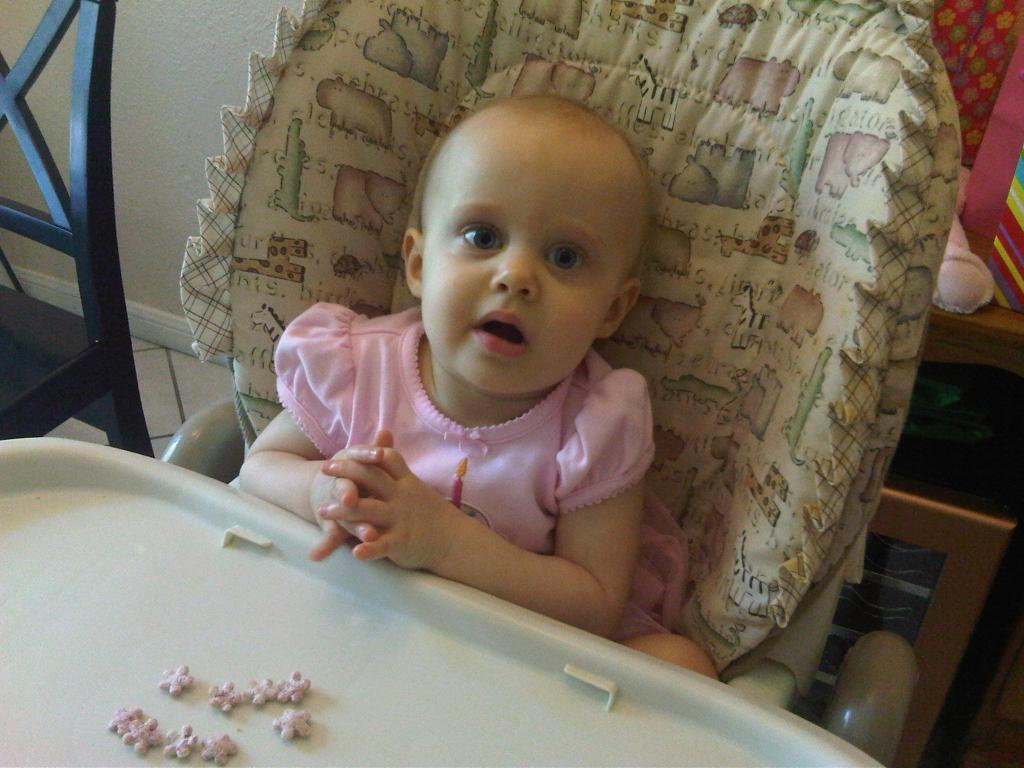What is the baby doing in the image? The baby is sitting on a chair in the image. Where is the baby positioned in relation to the table? The baby is in front of a table in the image. What is on the left side of the image? There is a chair on the left side of the image. What can be seen in the background of the image? There is a wall and cupboards in the background of the image. What type of mark does the baby make on the table in the image? There is no indication in the image that the baby makes any mark on the table. 